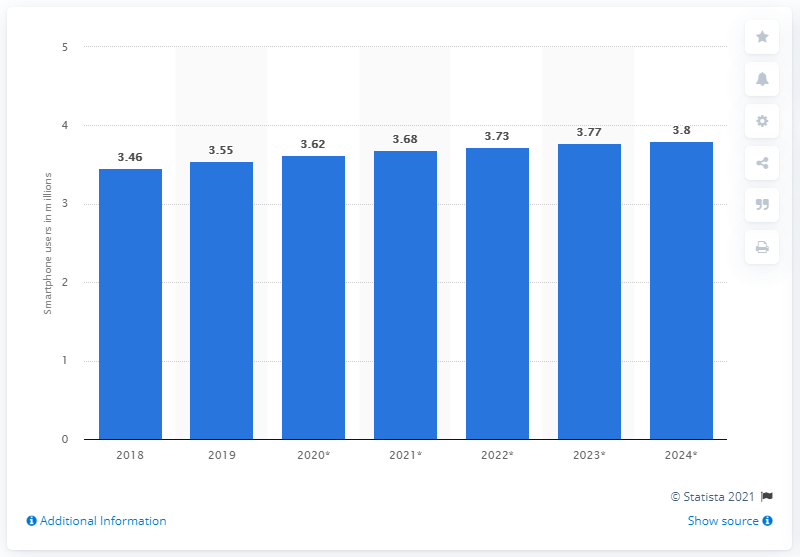Mention a couple of crucial points in this snapshot. It is estimated that by 2024, there will be approximately 3.8 million smartphone users in Ireland. 